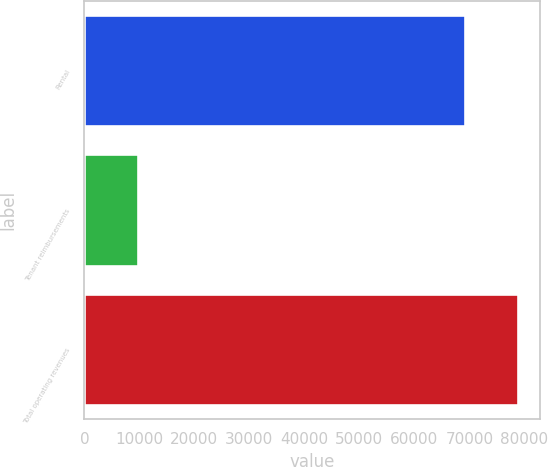Convert chart to OTSL. <chart><loc_0><loc_0><loc_500><loc_500><bar_chart><fcel>Rental<fcel>Tenant reimbursements<fcel>Total operating revenues<nl><fcel>69170<fcel>9718<fcel>78888<nl></chart> 